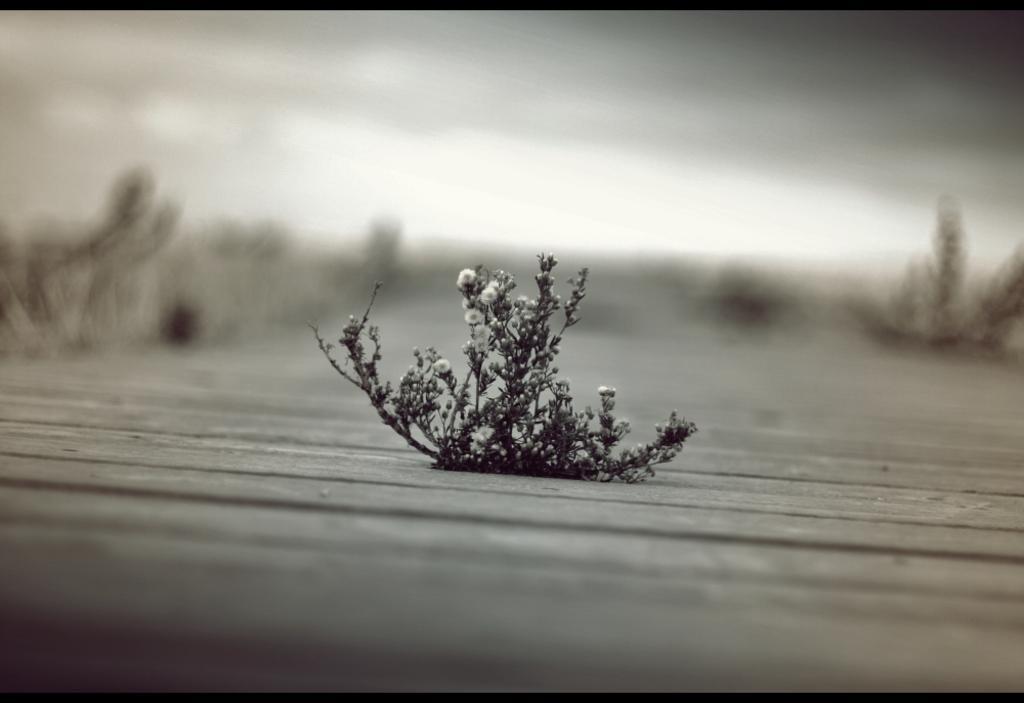Please provide a concise description of this image. This is black and white image where we can see a flower plant. 